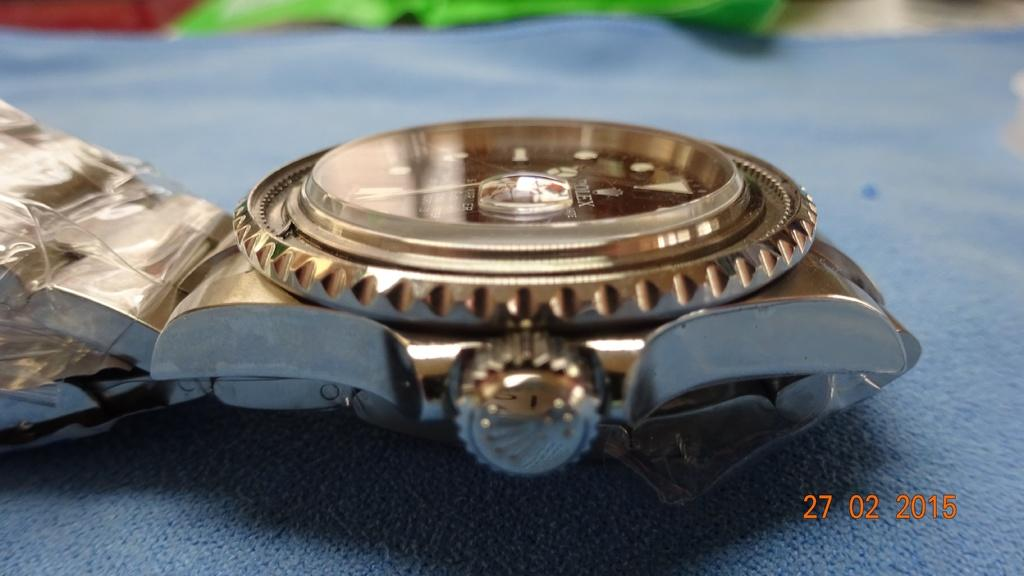<image>
Relay a brief, clear account of the picture shown. At the center of a watch face is the name Rolex. 